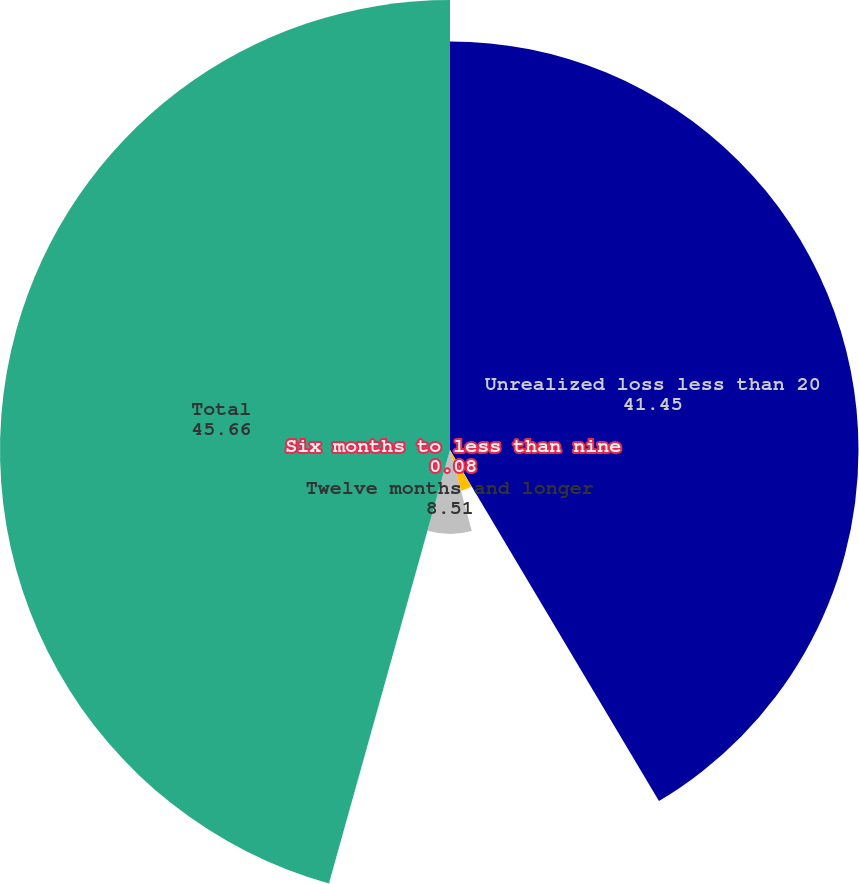Convert chart. <chart><loc_0><loc_0><loc_500><loc_500><pie_chart><fcel>Unrealized loss less than 20<fcel>Six months to less than nine<fcel>Nine months to less than<fcel>Twelve months and longer<fcel>Total<nl><fcel>41.45%<fcel>0.08%<fcel>4.29%<fcel>8.51%<fcel>45.66%<nl></chart> 